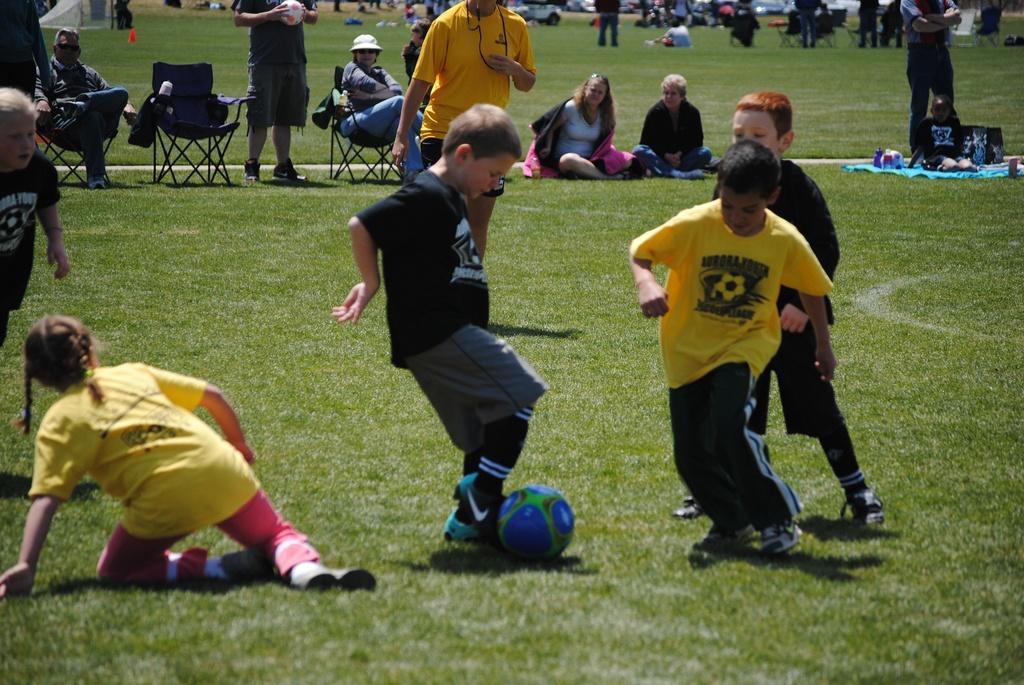Describe this image in one or two sentences. In the picture we can find some boys are playing a ball, one boy is kicking the ball and he is wearing a black T-shirt. And in the background there are some people sitting on the ground. There is a grass on the ground. 